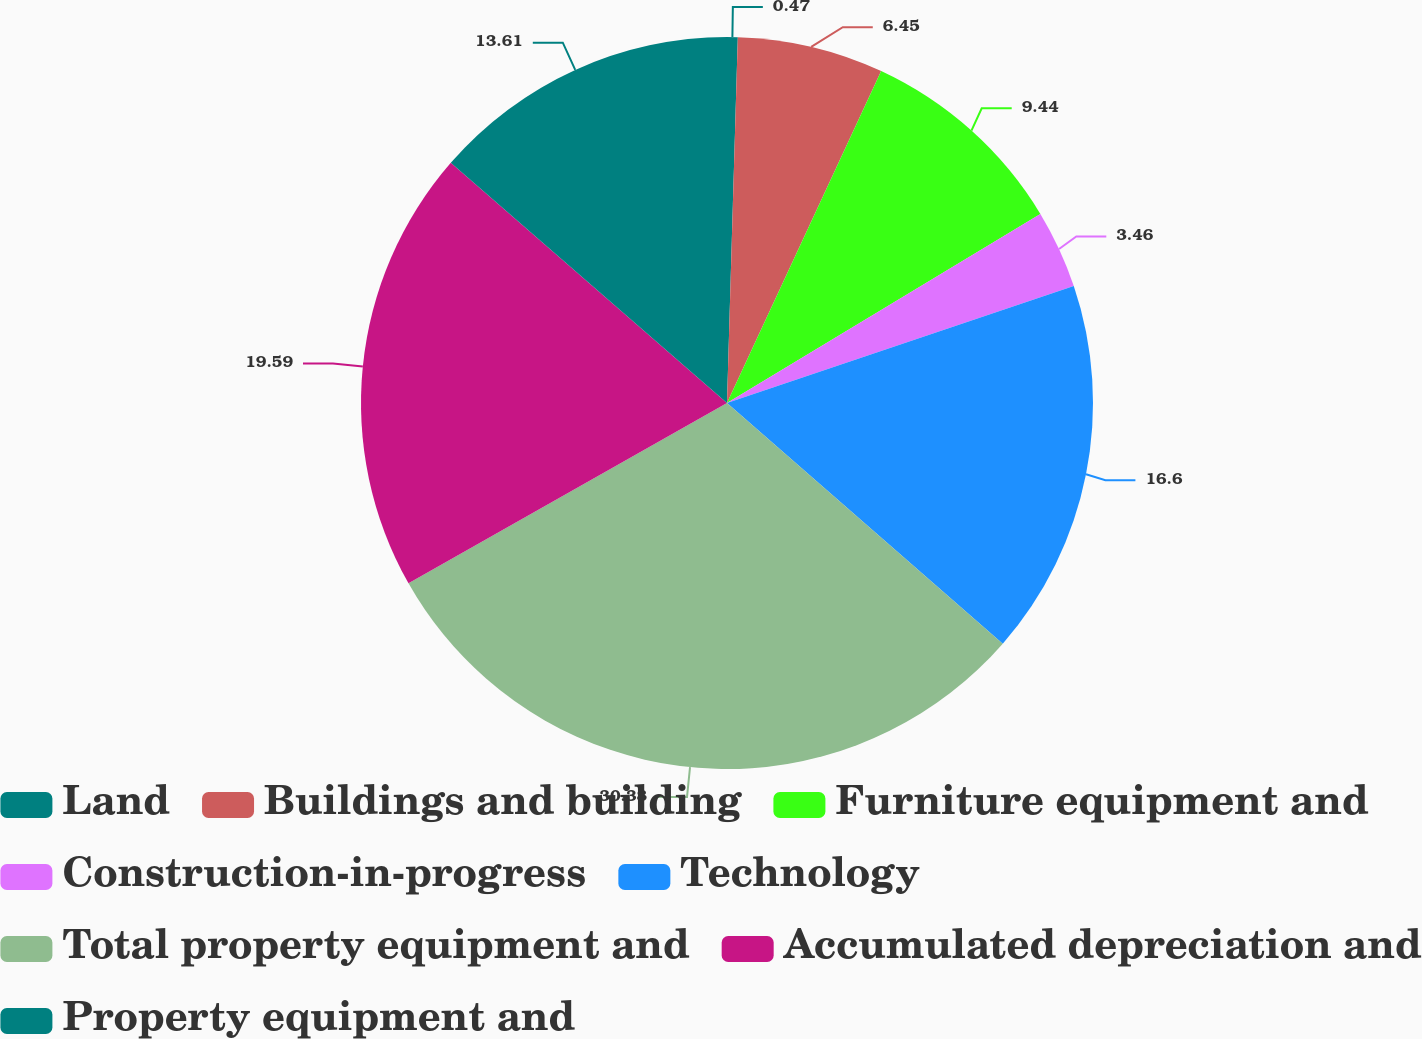Convert chart to OTSL. <chart><loc_0><loc_0><loc_500><loc_500><pie_chart><fcel>Land<fcel>Buildings and building<fcel>Furniture equipment and<fcel>Construction-in-progress<fcel>Technology<fcel>Total property equipment and<fcel>Accumulated depreciation and<fcel>Property equipment and<nl><fcel>0.47%<fcel>6.45%<fcel>9.44%<fcel>3.46%<fcel>16.6%<fcel>30.38%<fcel>19.59%<fcel>13.61%<nl></chart> 